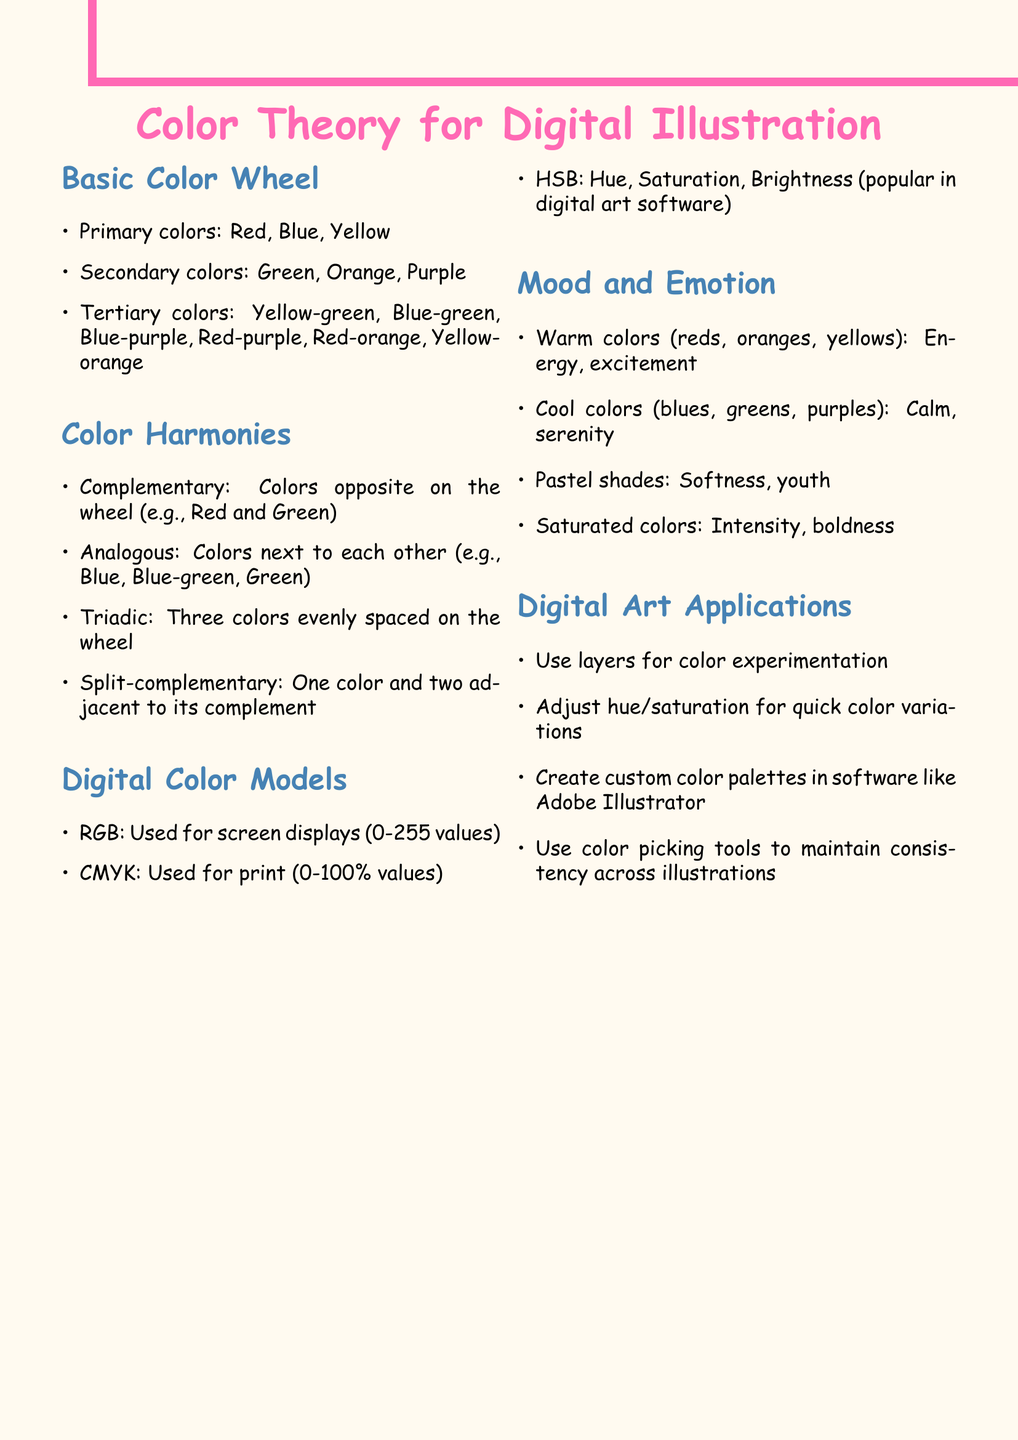What are the primary colors? The primary colors are mentioned in the section about the Basic Color Wheel.
Answer: Red, Blue, Yellow What is the RGB model used for? The RGB model is explained in the Digital Color Models section and its usage is specified.
Answer: Screen displays What colors make up the analogous harmony? The colors in the Analogous harmony are listed in the Color Harmonies section.
Answer: Blue, Blue-green, Green What do warm colors represent? The representation of warm colors is found in the Mood and Emotion section.
Answer: Energy, excitement Which tool is suggested for consistency across illustrations? A tool for maintaining consistency is mentioned in the Digital Art Applications section.
Answer: Color picking tools 